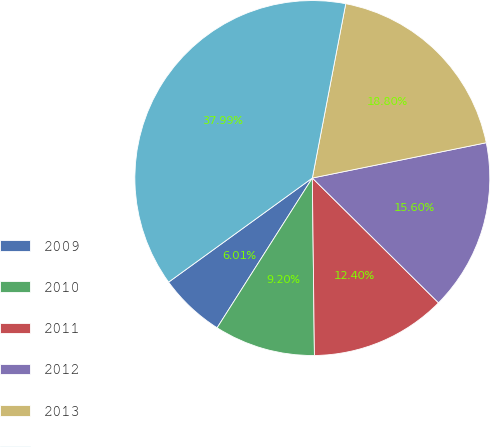Convert chart to OTSL. <chart><loc_0><loc_0><loc_500><loc_500><pie_chart><fcel>2009<fcel>2010<fcel>2011<fcel>2012<fcel>2013<fcel>2014-2018<nl><fcel>6.01%<fcel>9.2%<fcel>12.4%<fcel>15.6%<fcel>18.8%<fcel>37.99%<nl></chart> 